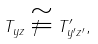<formula> <loc_0><loc_0><loc_500><loc_500>T _ { y z } \not \cong T ^ { \prime } _ { y ^ { \prime } z ^ { \prime } } ,</formula> 